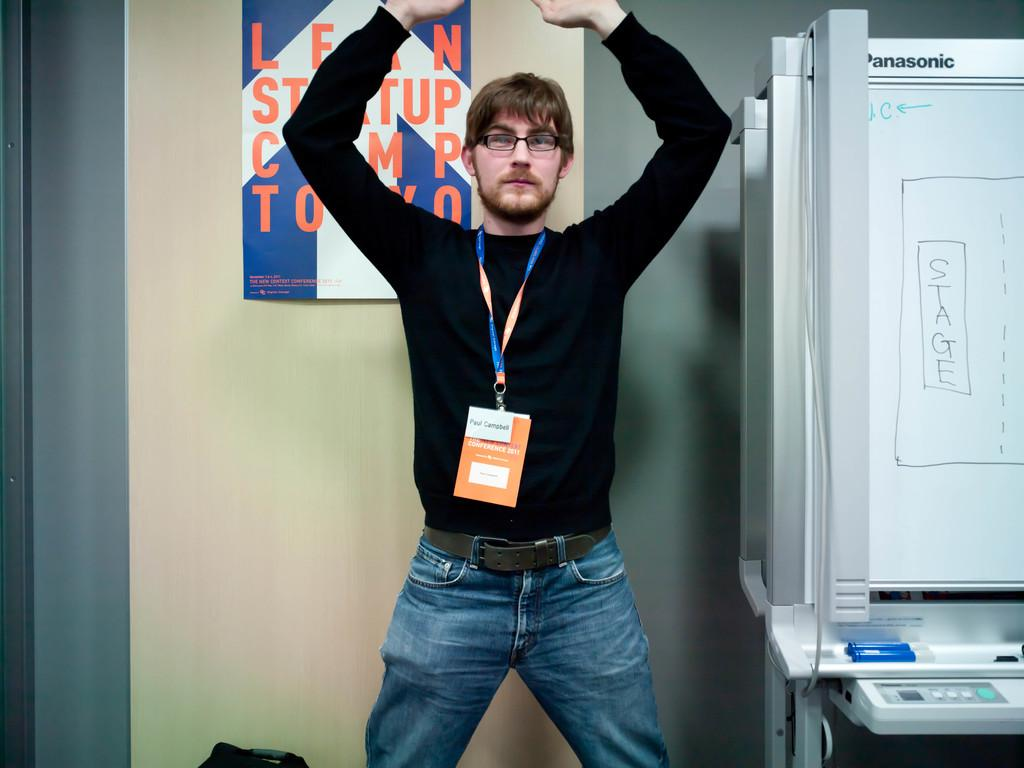<image>
Present a compact description of the photo's key features. Planning room featuring a white board with the word stage written across it. 